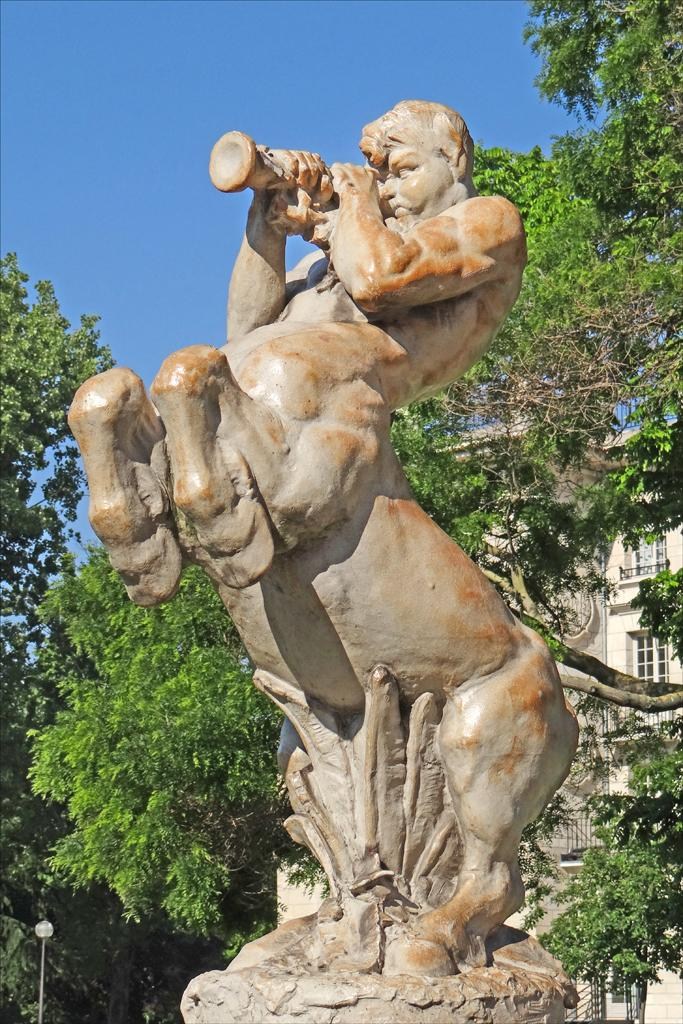What is the main subject in the image? There is a statue in the image. What other structures or objects can be seen in the image? There is a building in the image. Are there any natural elements present in the image? Yes, there are trees in the image. What can be seen in the background of the image? The sky is visible in the background of the image. How many kittens are sleeping on the statue's chin in the image? There are no kittens present in the image, and the statue does not have a chin. 